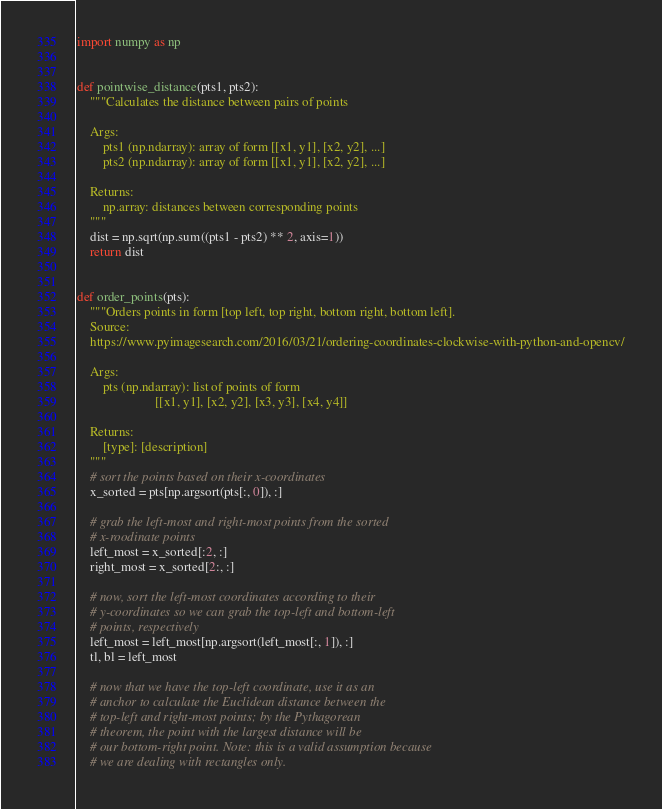<code> <loc_0><loc_0><loc_500><loc_500><_Python_>import numpy as np


def pointwise_distance(pts1, pts2):
    """Calculates the distance between pairs of points

    Args:
        pts1 (np.ndarray): array of form [[x1, y1], [x2, y2], ...]
        pts2 (np.ndarray): array of form [[x1, y1], [x2, y2], ...]

    Returns:
        np.array: distances between corresponding points
    """
    dist = np.sqrt(np.sum((pts1 - pts2) ** 2, axis=1))
    return dist


def order_points(pts):
    """Orders points in form [top left, top right, bottom right, bottom left].
    Source:
    https://www.pyimagesearch.com/2016/03/21/ordering-coordinates-clockwise-with-python-and-opencv/

    Args:
        pts (np.ndarray): list of points of form
                        [[x1, y1], [x2, y2], [x3, y3], [x4, y4]]

    Returns:
        [type]: [description]
    """
    # sort the points based on their x-coordinates
    x_sorted = pts[np.argsort(pts[:, 0]), :]

    # grab the left-most and right-most points from the sorted
    # x-roodinate points
    left_most = x_sorted[:2, :]
    right_most = x_sorted[2:, :]

    # now, sort the left-most coordinates according to their
    # y-coordinates so we can grab the top-left and bottom-left
    # points, respectively
    left_most = left_most[np.argsort(left_most[:, 1]), :]
    tl, bl = left_most

    # now that we have the top-left coordinate, use it as an
    # anchor to calculate the Euclidean distance between the
    # top-left and right-most points; by the Pythagorean
    # theorem, the point with the largest distance will be
    # our bottom-right point. Note: this is a valid assumption because
    # we are dealing with rectangles only.</code> 